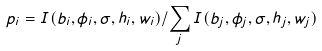<formula> <loc_0><loc_0><loc_500><loc_500>p _ { i } = I ( b _ { i } , \phi _ { i } , \sigma , h _ { i } , w _ { i } ) / \sum _ { j } I ( b _ { j } , \phi _ { j } , \sigma , h _ { j } , w _ { j } )</formula> 